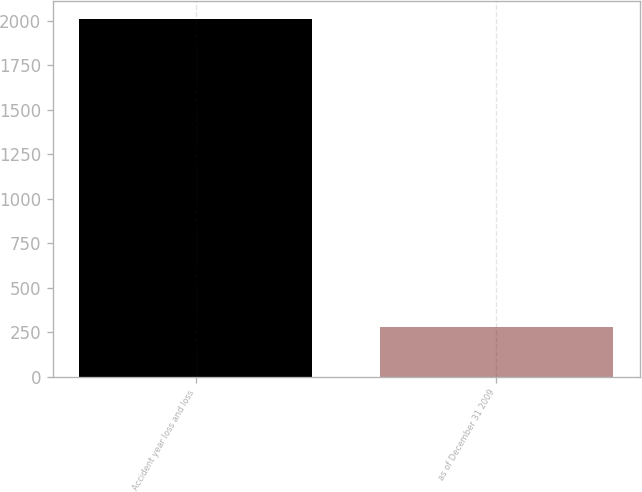Convert chart. <chart><loc_0><loc_0><loc_500><loc_500><bar_chart><fcel>Accident year loss and loss<fcel>as of December 31 2009<nl><fcel>2008<fcel>281<nl></chart> 